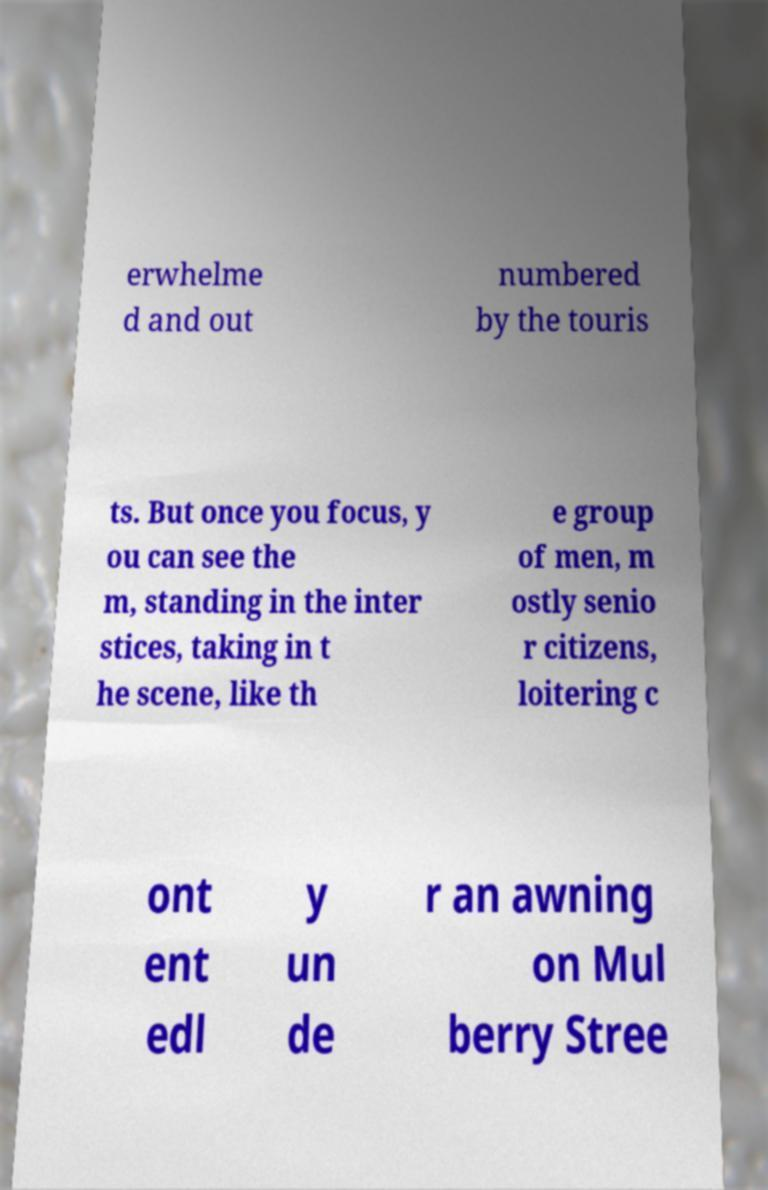Please identify and transcribe the text found in this image. erwhelme d and out numbered by the touris ts. But once you focus, y ou can see the m, standing in the inter stices, taking in t he scene, like th e group of men, m ostly senio r citizens, loitering c ont ent edl y un de r an awning on Mul berry Stree 